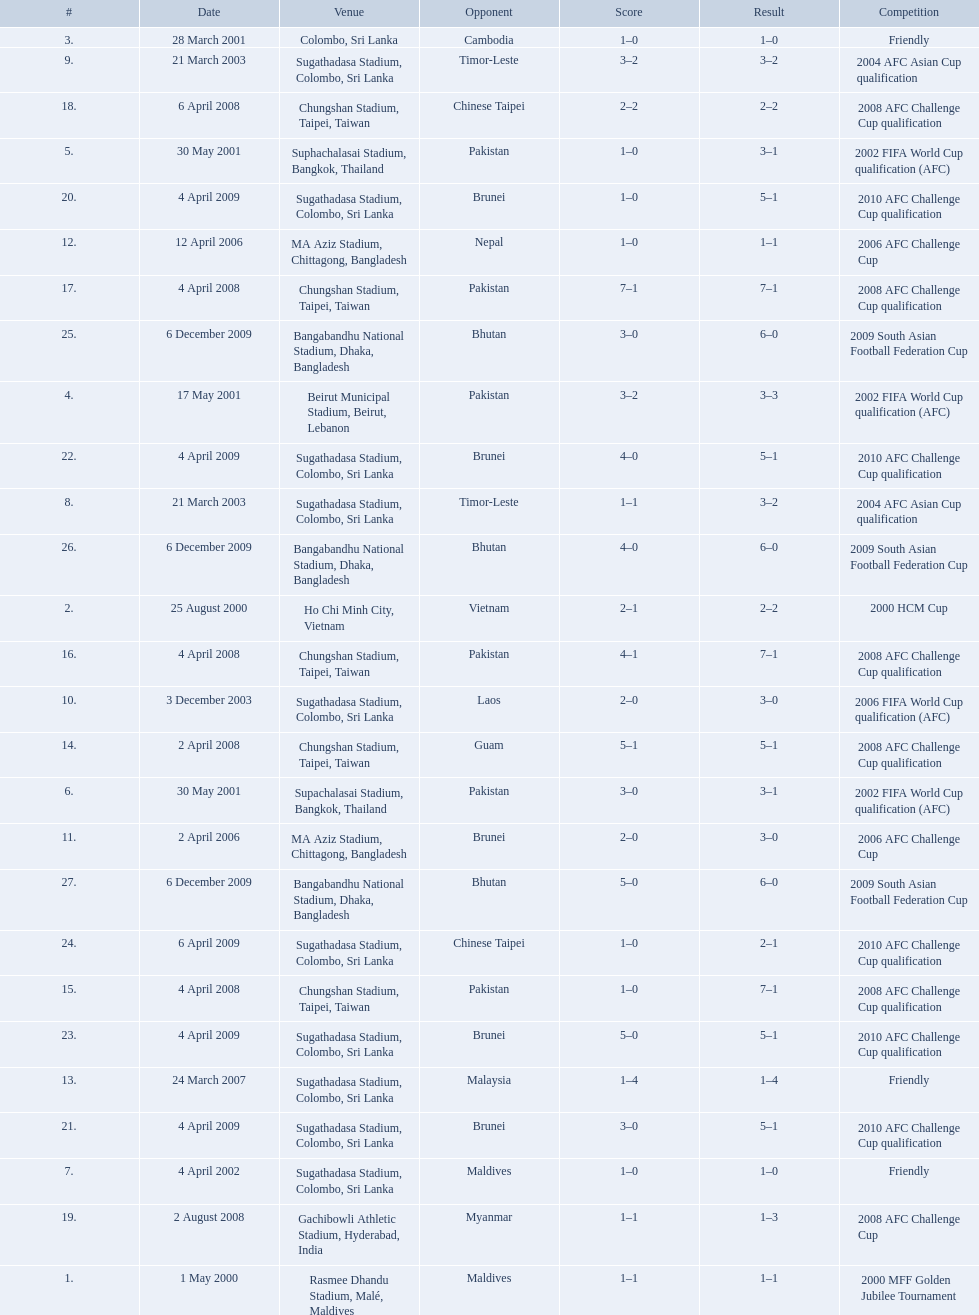What are the venues Rasmee Dhandu Stadium, Malé, Maldives, Ho Chi Minh City, Vietnam, Colombo, Sri Lanka, Beirut Municipal Stadium, Beirut, Lebanon, Suphachalasai Stadium, Bangkok, Thailand, Supachalasai Stadium, Bangkok, Thailand, Sugathadasa Stadium, Colombo, Sri Lanka, Sugathadasa Stadium, Colombo, Sri Lanka, Sugathadasa Stadium, Colombo, Sri Lanka, Sugathadasa Stadium, Colombo, Sri Lanka, MA Aziz Stadium, Chittagong, Bangladesh, MA Aziz Stadium, Chittagong, Bangladesh, Sugathadasa Stadium, Colombo, Sri Lanka, Chungshan Stadium, Taipei, Taiwan, Chungshan Stadium, Taipei, Taiwan, Chungshan Stadium, Taipei, Taiwan, Chungshan Stadium, Taipei, Taiwan, Chungshan Stadium, Taipei, Taiwan, Gachibowli Athletic Stadium, Hyderabad, India, Sugathadasa Stadium, Colombo, Sri Lanka, Sugathadasa Stadium, Colombo, Sri Lanka, Sugathadasa Stadium, Colombo, Sri Lanka, Sugathadasa Stadium, Colombo, Sri Lanka, Sugathadasa Stadium, Colombo, Sri Lanka, Bangabandhu National Stadium, Dhaka, Bangladesh, Bangabandhu National Stadium, Dhaka, Bangladesh, Bangabandhu National Stadium, Dhaka, Bangladesh. What are the #'s? 1., 2., 3., 4., 5., 6., 7., 8., 9., 10., 11., 12., 13., 14., 15., 16., 17., 18., 19., 20., 21., 22., 23., 24., 25., 26., 27. Which one is #1? Rasmee Dhandu Stadium, Malé, Maldives. What venues are listed? Rasmee Dhandu Stadium, Malé, Maldives, Ho Chi Minh City, Vietnam, Colombo, Sri Lanka, Beirut Municipal Stadium, Beirut, Lebanon, Suphachalasai Stadium, Bangkok, Thailand, MA Aziz Stadium, Chittagong, Bangladesh, Sugathadasa Stadium, Colombo, Sri Lanka, Chungshan Stadium, Taipei, Taiwan, Gachibowli Athletic Stadium, Hyderabad, India, Sugathadasa Stadium, Colombo, Sri Lanka, Bangabandhu National Stadium, Dhaka, Bangladesh. Which is top listed? Rasmee Dhandu Stadium, Malé, Maldives. 